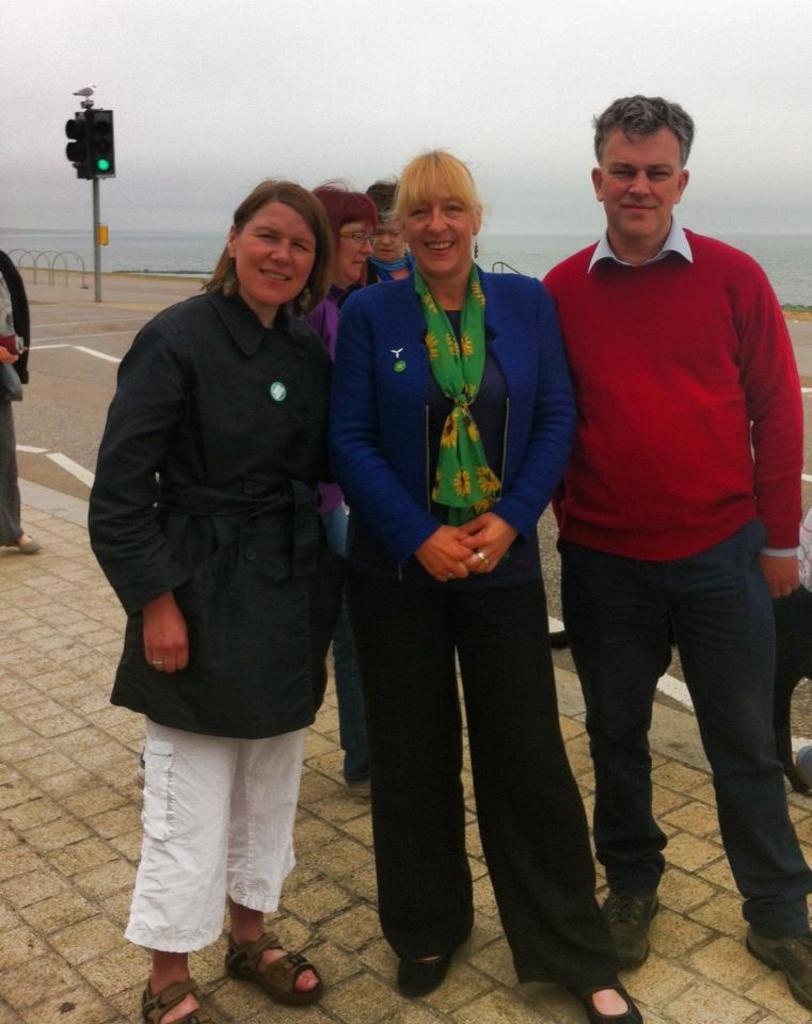Please provide a concise description of this image. In this image I can see the group of people are standing to the side of the road. I can see these people are wearing the different color dresses. In the background I can see the signal pole and there is a bird on it. I can see the water and the sky in the back. 